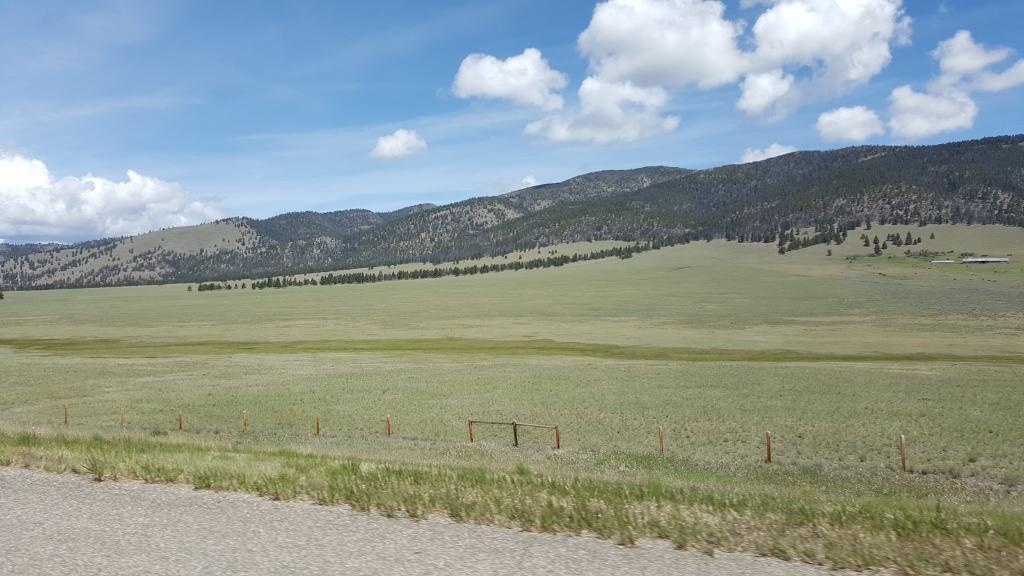Describe this image in one or two sentences. In this picture I can see hills and few trees and I can see grass on the ground and I can see blue cloudy sky. 